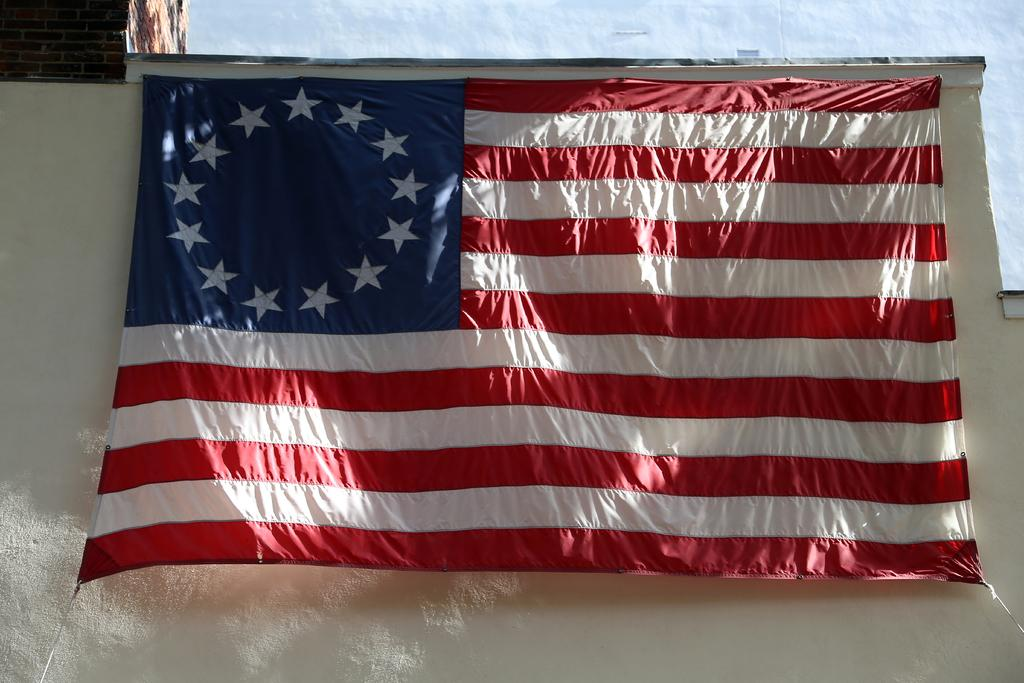What is the main object in the image? There is a flag in the image. What colors are present on the flag? The flag has red, blue, and white colors. What is the color of the background in the image? The background of the image is white. What type of property is being taught by the guide in the image? There is no guide or property present in the image; it only features a flag with specific colors against a white background. 